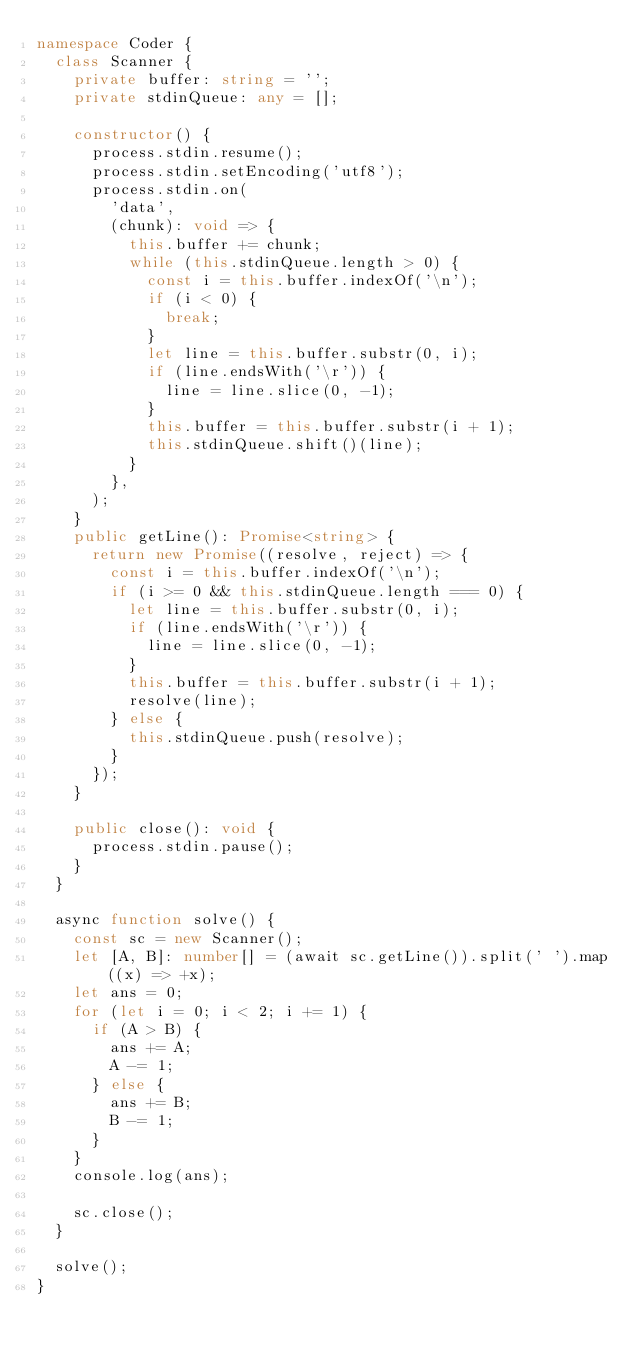Convert code to text. <code><loc_0><loc_0><loc_500><loc_500><_TypeScript_>namespace Coder {
  class Scanner {
    private buffer: string = '';
    private stdinQueue: any = [];

    constructor() {
      process.stdin.resume();
      process.stdin.setEncoding('utf8');
      process.stdin.on(
        'data',
        (chunk): void => {
          this.buffer += chunk;
          while (this.stdinQueue.length > 0) {
            const i = this.buffer.indexOf('\n');
            if (i < 0) {
              break;
            }
            let line = this.buffer.substr(0, i);
            if (line.endsWith('\r')) {
              line = line.slice(0, -1);
            }
            this.buffer = this.buffer.substr(i + 1);
            this.stdinQueue.shift()(line);
          }
        },
      );
    }
    public getLine(): Promise<string> {
      return new Promise((resolve, reject) => {
        const i = this.buffer.indexOf('\n');
        if (i >= 0 && this.stdinQueue.length === 0) {
          let line = this.buffer.substr(0, i);
          if (line.endsWith('\r')) {
            line = line.slice(0, -1);
          }
          this.buffer = this.buffer.substr(i + 1);
          resolve(line);
        } else {
          this.stdinQueue.push(resolve);
        }
      });
    }

    public close(): void {
      process.stdin.pause();
    }
  }

  async function solve() {
    const sc = new Scanner();
    let [A, B]: number[] = (await sc.getLine()).split(' ').map((x) => +x);
    let ans = 0;
    for (let i = 0; i < 2; i += 1) {
      if (A > B) {
        ans += A;
        A -= 1;
      } else {
        ans += B;
        B -= 1;
      }
    }
    console.log(ans);

    sc.close();
  }

  solve();
}
</code> 